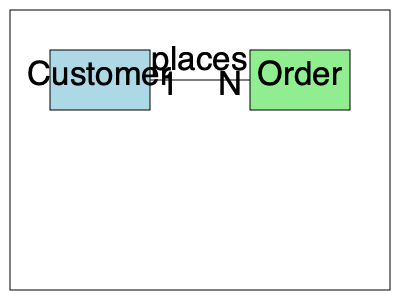Based on the entity-relationship diagram shown, what is the cardinality of the relationship between Customer and Order entities? To determine the cardinality of the relationship between Customer and Order entities, we need to analyze the diagram step-by-step:

1. Identify the entities: We have two entities, Customer and Order.

2. Locate the relationship: There is a line connecting the two entities with the label "places" indicating the relationship.

3. Examine the cardinality symbols:
   - Near the Customer entity, we see "1"
   - Near the Order entity, we see "N"

4. Interpret the cardinality:
   - "1" on the Customer side means that one customer is associated with the relationship.
   - "N" on the Order side means that many orders can be associated with the relationship.

5. Combine the interpretations:
   - This indicates a one-to-many relationship between Customer and Order.

6. Express the cardinality:
   - In database terms, this is typically expressed as "1:N" or "1 to Many"

Therefore, the cardinality of the relationship between Customer and Order is one-to-many (1:N), meaning one customer can place many orders.
Answer: One-to-Many (1:N) 